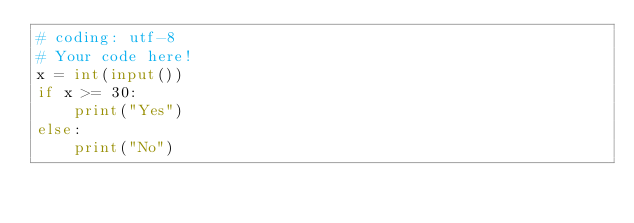<code> <loc_0><loc_0><loc_500><loc_500><_Python_># coding: utf-8
# Your code here!
x = int(input())
if x >= 30:
    print("Yes")
else:
    print("No")</code> 